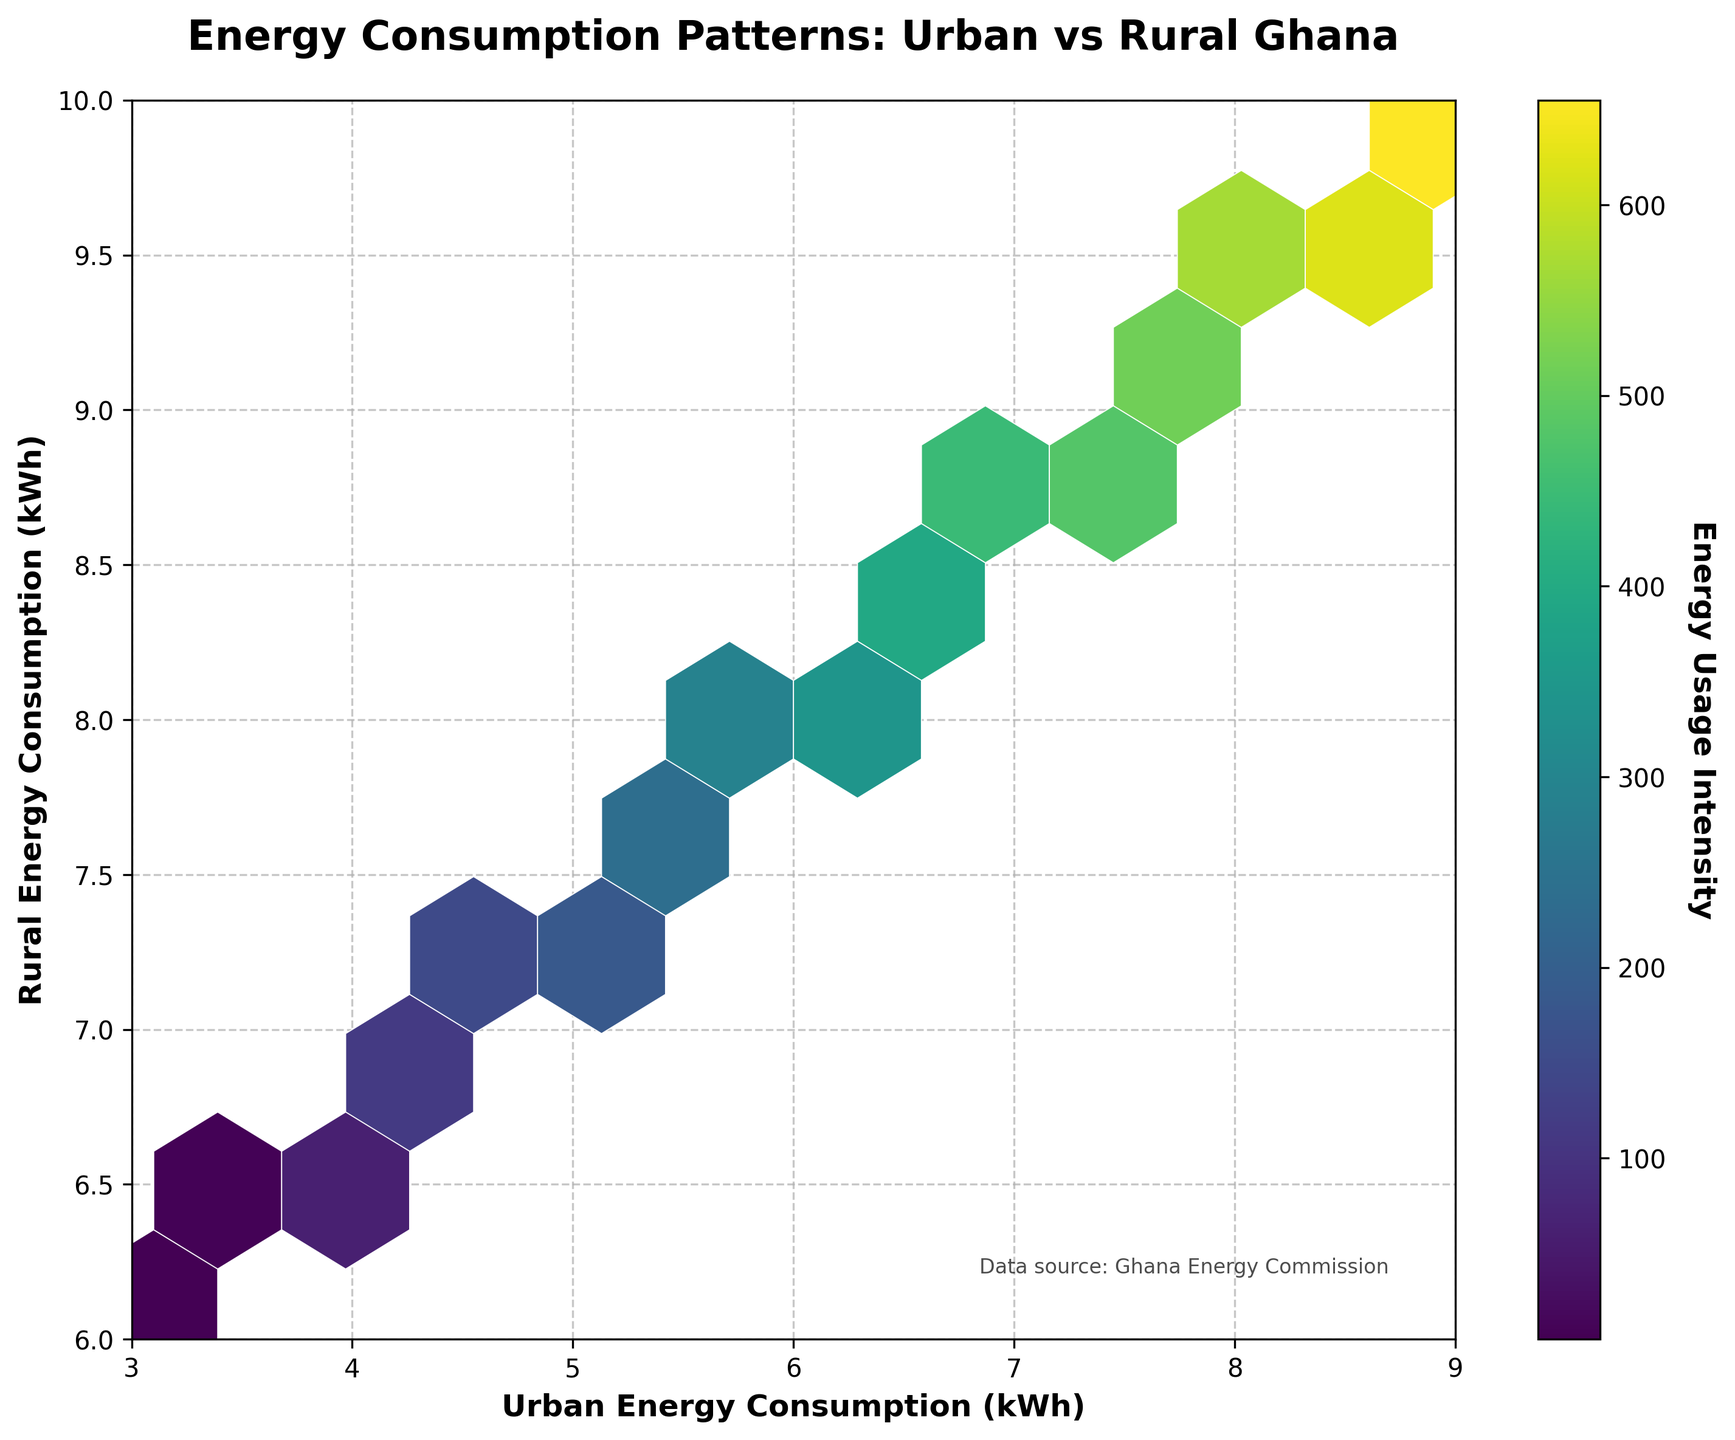How many data points are plotted on the hexbin plot? By counting the total number of entries in the data, we see that there are 20 unique data points in the plot.
Answer: 20 What does the color intensity represent in the hexbin plot? The color intensity represents the energy usage intensity, indicated by the colorbar on the side of the plot.
Answer: Energy usage intensity Which area appears to have higher energy consumption, urban or rural? By examining the hexbin plot, the x-axis (Urban Energy Consumption) generally has higher values (closer to 8-9 kWh) where the color intensity is higher, compared to the y-axis (Rural Energy Consumption).
Answer: Urban What is the relationship between urban energy consumption and rural energy consumption? Observing the plot, there is a positive correlation between urban and rural energy consumption; as urban energy consumption increases, rural energy consumption also increases.
Answer: Positive correlation Are there any hexagons indicating particularly high energy usage intensity? Yes, the hexagons towards the upper right corner of the plot show higher energy usage intensity, as indicated by darker colors.
Answer: Yes What is the energy usage intensity for the hexbin located around urban consumption of 6 kWh and rural consumption of 8 kWh? By matching this location on the plot with the color intensity, and cross-referencing with the colorbar, the energy usage intensity in that region is around 300-350.
Answer: Around 300-350 Which region exhibits the lowest energy consumption pattern in both urban and rural areas? The lower left corner of the plot (around urban consumption of 3.1-3.4 kWh and rural consumption of 6.1-6.3 kWh) shows the lowest energy usage intensity, indicated by lighter colors.
Answer: Lower left corner How does the energy consumption pattern change as we move from 4 kWh to 8 kWh on the urban axis? As we move from 4 kWh to 8 kWh on the urban axis, the energy consumption in rural areas also increases, which is indicated by the range in the y-axis of about 6 kWh to 10 kWh, and the color intensity generally gets darker, indicating higher energy usage intensity.
Answer: Energy consumption increases Based on the plot, which specific area in terms of urban and rural consumption seems to have the most concentrated high energy usage intensity? The area around urban consumption of 8-8.9 kWh and rural consumption of 9-9.7 kWh shows the darkest colors, indicating the most concentrated high energy usage intensity.
Answer: Around urban 8-8.9 kWh and rural 9-9.7 kWh 